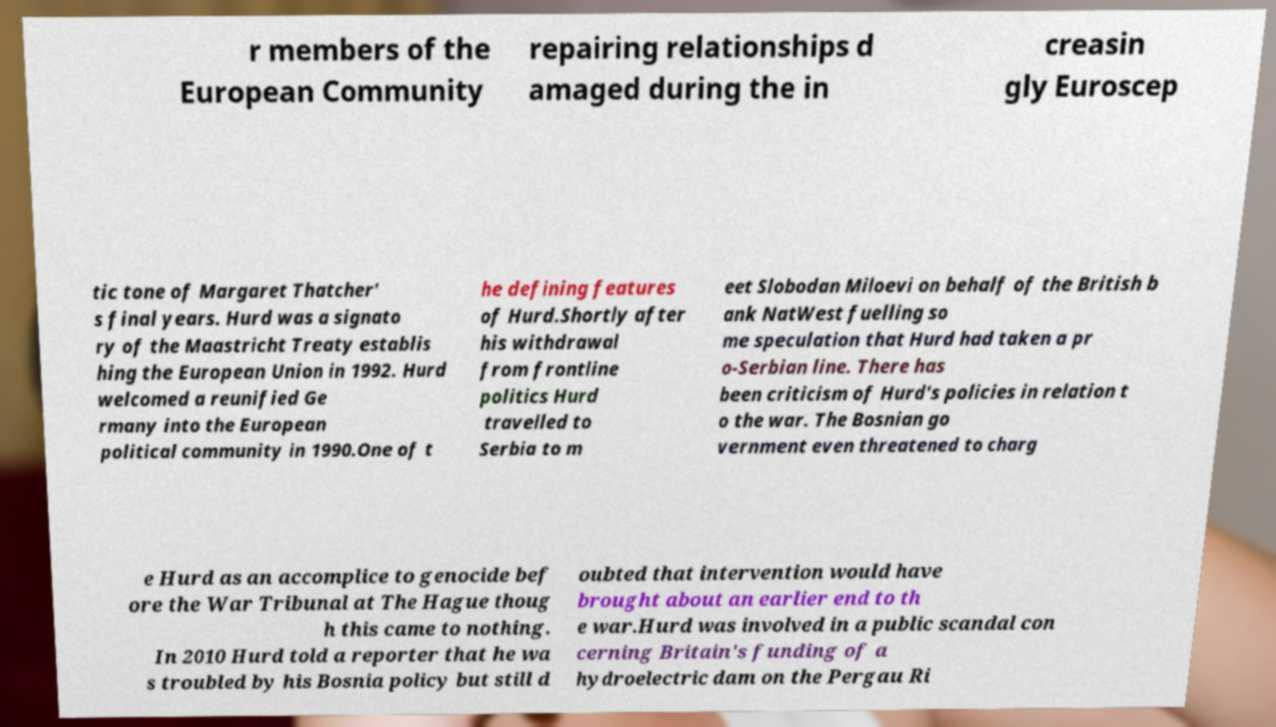Can you read and provide the text displayed in the image?This photo seems to have some interesting text. Can you extract and type it out for me? r members of the European Community repairing relationships d amaged during the in creasin gly Euroscep tic tone of Margaret Thatcher' s final years. Hurd was a signato ry of the Maastricht Treaty establis hing the European Union in 1992. Hurd welcomed a reunified Ge rmany into the European political community in 1990.One of t he defining features of Hurd.Shortly after his withdrawal from frontline politics Hurd travelled to Serbia to m eet Slobodan Miloevi on behalf of the British b ank NatWest fuelling so me speculation that Hurd had taken a pr o-Serbian line. There has been criticism of Hurd's policies in relation t o the war. The Bosnian go vernment even threatened to charg e Hurd as an accomplice to genocide bef ore the War Tribunal at The Hague thoug h this came to nothing. In 2010 Hurd told a reporter that he wa s troubled by his Bosnia policy but still d oubted that intervention would have brought about an earlier end to th e war.Hurd was involved in a public scandal con cerning Britain's funding of a hydroelectric dam on the Pergau Ri 